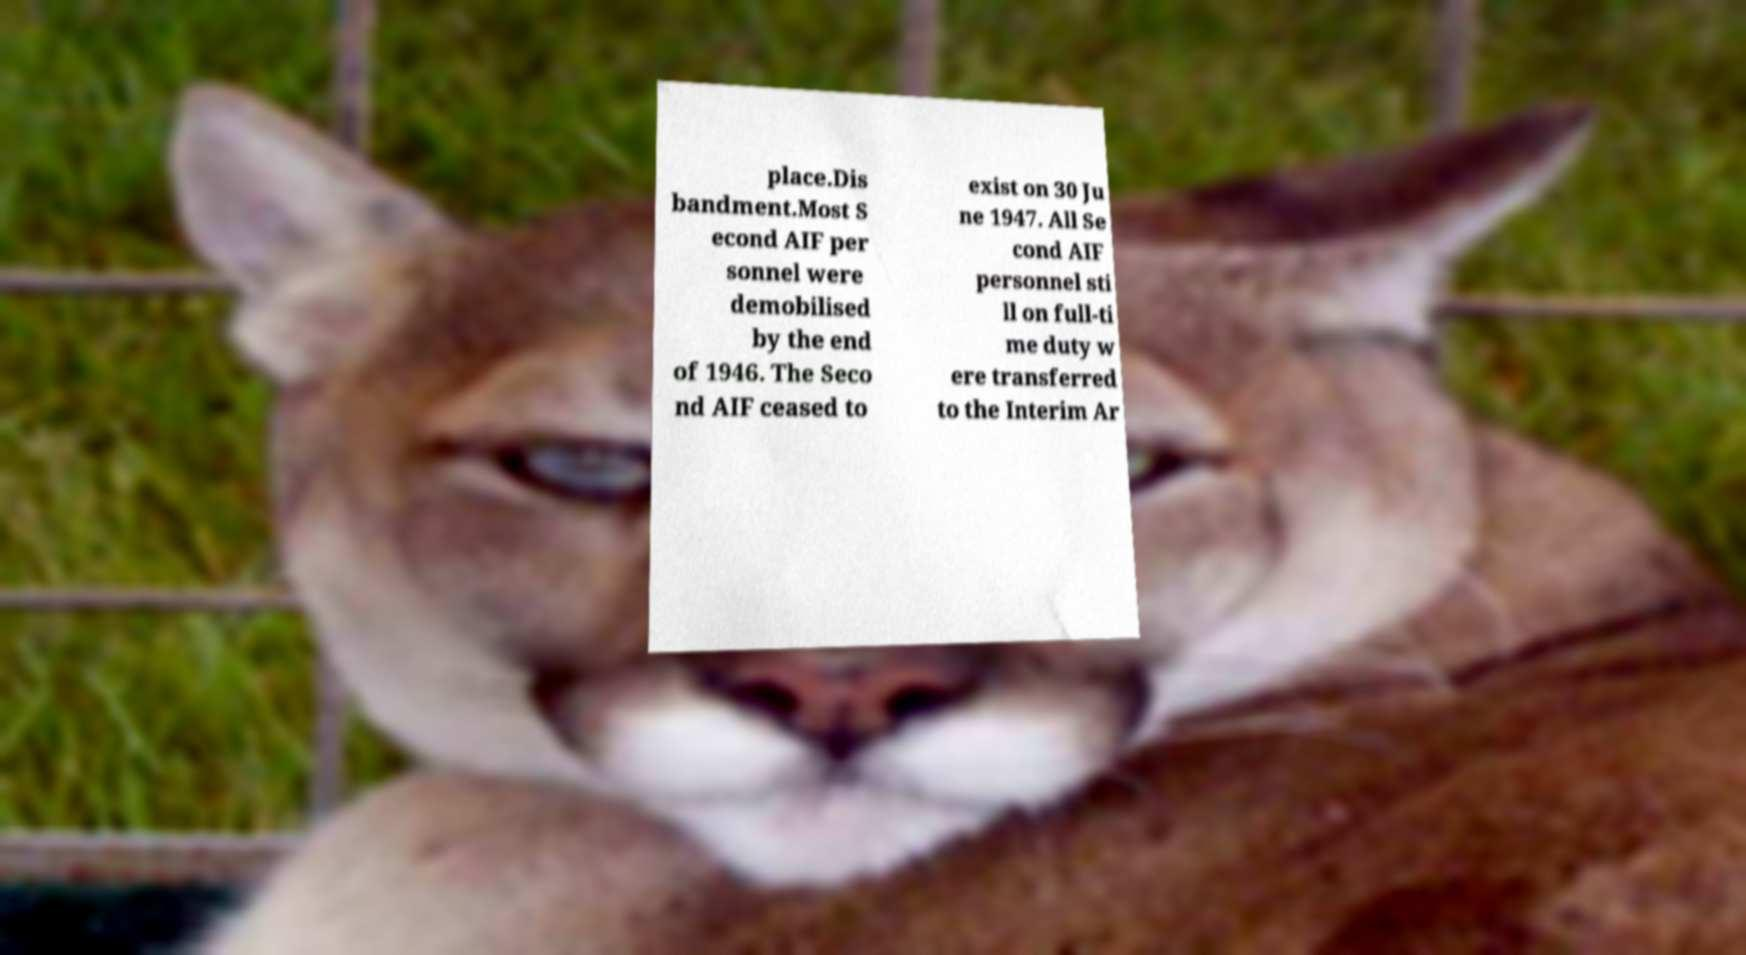What messages or text are displayed in this image? I need them in a readable, typed format. place.Dis bandment.Most S econd AIF per sonnel were demobilised by the end of 1946. The Seco nd AIF ceased to exist on 30 Ju ne 1947. All Se cond AIF personnel sti ll on full-ti me duty w ere transferred to the Interim Ar 